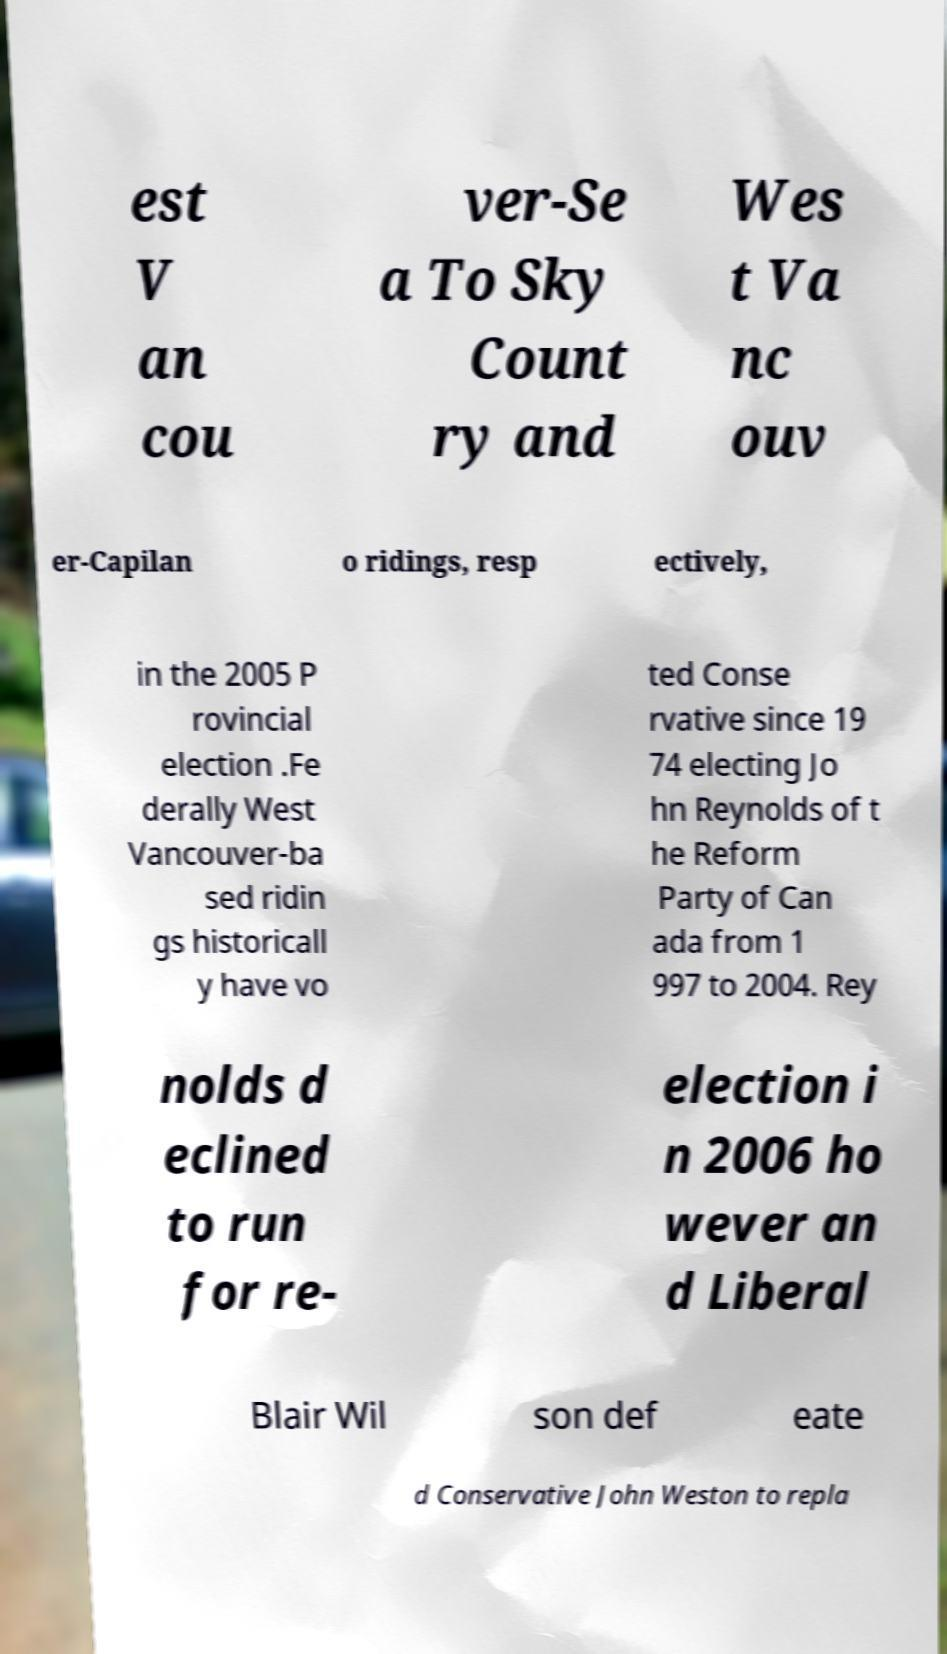Could you assist in decoding the text presented in this image and type it out clearly? est V an cou ver-Se a To Sky Count ry and Wes t Va nc ouv er-Capilan o ridings, resp ectively, in the 2005 P rovincial election .Fe derally West Vancouver-ba sed ridin gs historicall y have vo ted Conse rvative since 19 74 electing Jo hn Reynolds of t he Reform Party of Can ada from 1 997 to 2004. Rey nolds d eclined to run for re- election i n 2006 ho wever an d Liberal Blair Wil son def eate d Conservative John Weston to repla 